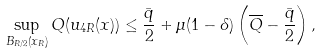Convert formula to latex. <formula><loc_0><loc_0><loc_500><loc_500>\sup _ { B _ { R / 2 } ( x _ { R } ) } Q ( u _ { 4 R } ( x ) ) \leq \frac { \bar { q } } { 2 } + \mu ( 1 - \delta ) \left ( \overline { Q } - \frac { \bar { q } } { 2 } \right ) ,</formula> 